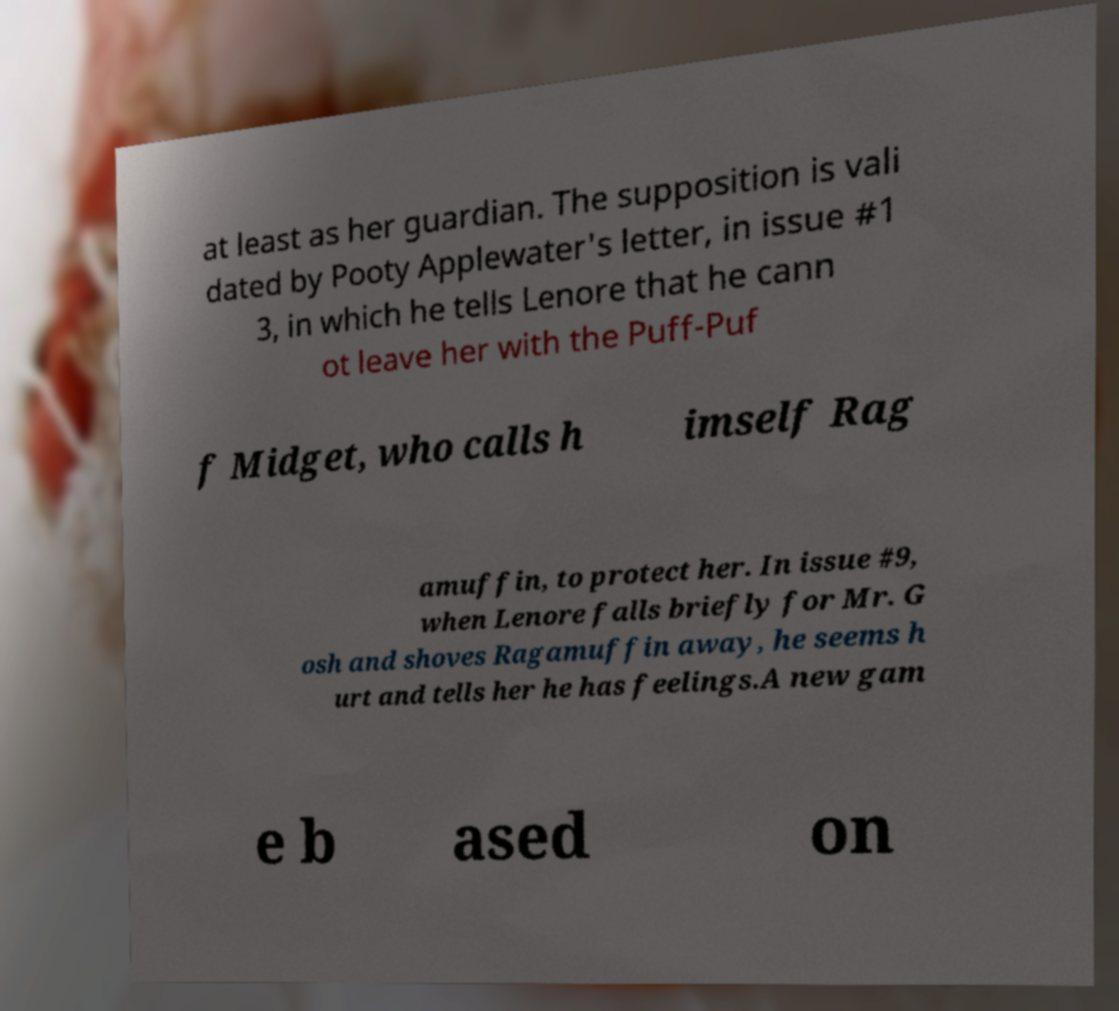Can you read and provide the text displayed in the image?This photo seems to have some interesting text. Can you extract and type it out for me? at least as her guardian. The supposition is vali dated by Pooty Applewater's letter, in issue #1 3, in which he tells Lenore that he cann ot leave her with the Puff-Puf f Midget, who calls h imself Rag amuffin, to protect her. In issue #9, when Lenore falls briefly for Mr. G osh and shoves Ragamuffin away, he seems h urt and tells her he has feelings.A new gam e b ased on 